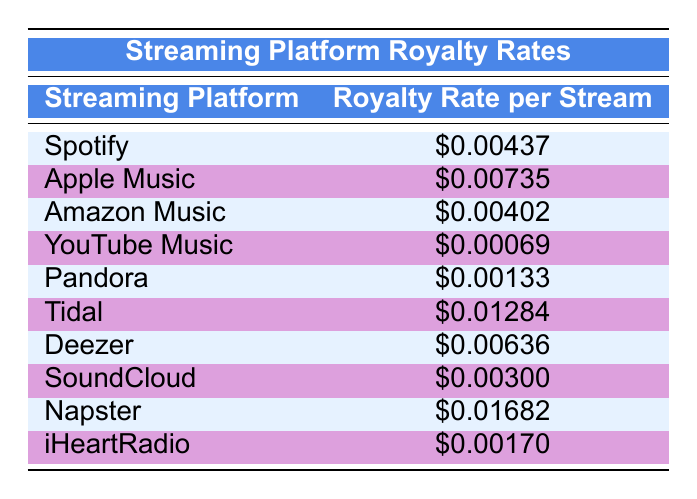What is the royalty rate per stream on Spotify? The table specifies that the royalty rate per stream on Spotify is listed in the second column for Spotify, which shows $0.00437.
Answer: $0.00437 Which streaming platform offers the highest royalty rate? To determine which platform offers the highest royalty rate, I can compare all the values in the second column. Napster has the highest value at $0.01682.
Answer: Napster What is the average royalty rate of Apple Music and Tidal combined? The average is calculated by first adding the royalty rates of Apple Music ($0.00735) and Tidal ($0.01284), which equals $0.02019. Then, divide by 2: $0.02019 / 2 = $0.010095.
Answer: $0.010095 Is the royal rate for YouTube Music greater than the rate for Pandora? To answer this, I'll compare the rates: YouTube Music's rate is $0.00069, while Pandora's is $0.00133. Since $0.00069 is less than $0.00133, the answer is no.
Answer: No What is the difference between the royalty rates of Deezer and SoundCloud? The rate for Deezer is $0.00636 and for SoundCloud, it is $0.00300. The difference can be found by subtracting SoundCloud's rate from Deezer's: $0.00636 - $0.00300 = $0.00336.
Answer: $0.00336 Is the average royalty rate among the platforms above $0.005? To find the average, I sum all the royalty rates: (0.00437 + 0.00735 + 0.00402 + 0.00069 + 0.00133 + 0.01284 + 0.00636 + 0.00300 + 0.01682 + 0.00170) = $0.05847. Then, divide by the number of platforms (10): $0.05847 / 10 ≈ $0.005847, which is greater than $0.005.
Answer: Yes Which platform has a rate lower than $0.002? I check each platform's royalty rate in the table and identify those less than $0.002. YouTube Music ($0.00069) and Pandora ($0.00133) fall below this threshold.
Answer: YouTube Music and Pandora How much more does Tidal pay per stream compared to Amazon Music? First, I identify the rates: Tidal pays $0.01284 and Amazon Music pays $0.00402. The difference is found by subtracting Amazon Music's rate from Tidal's: $0.01284 - $0.00402 = $0.00882.
Answer: $0.00882 